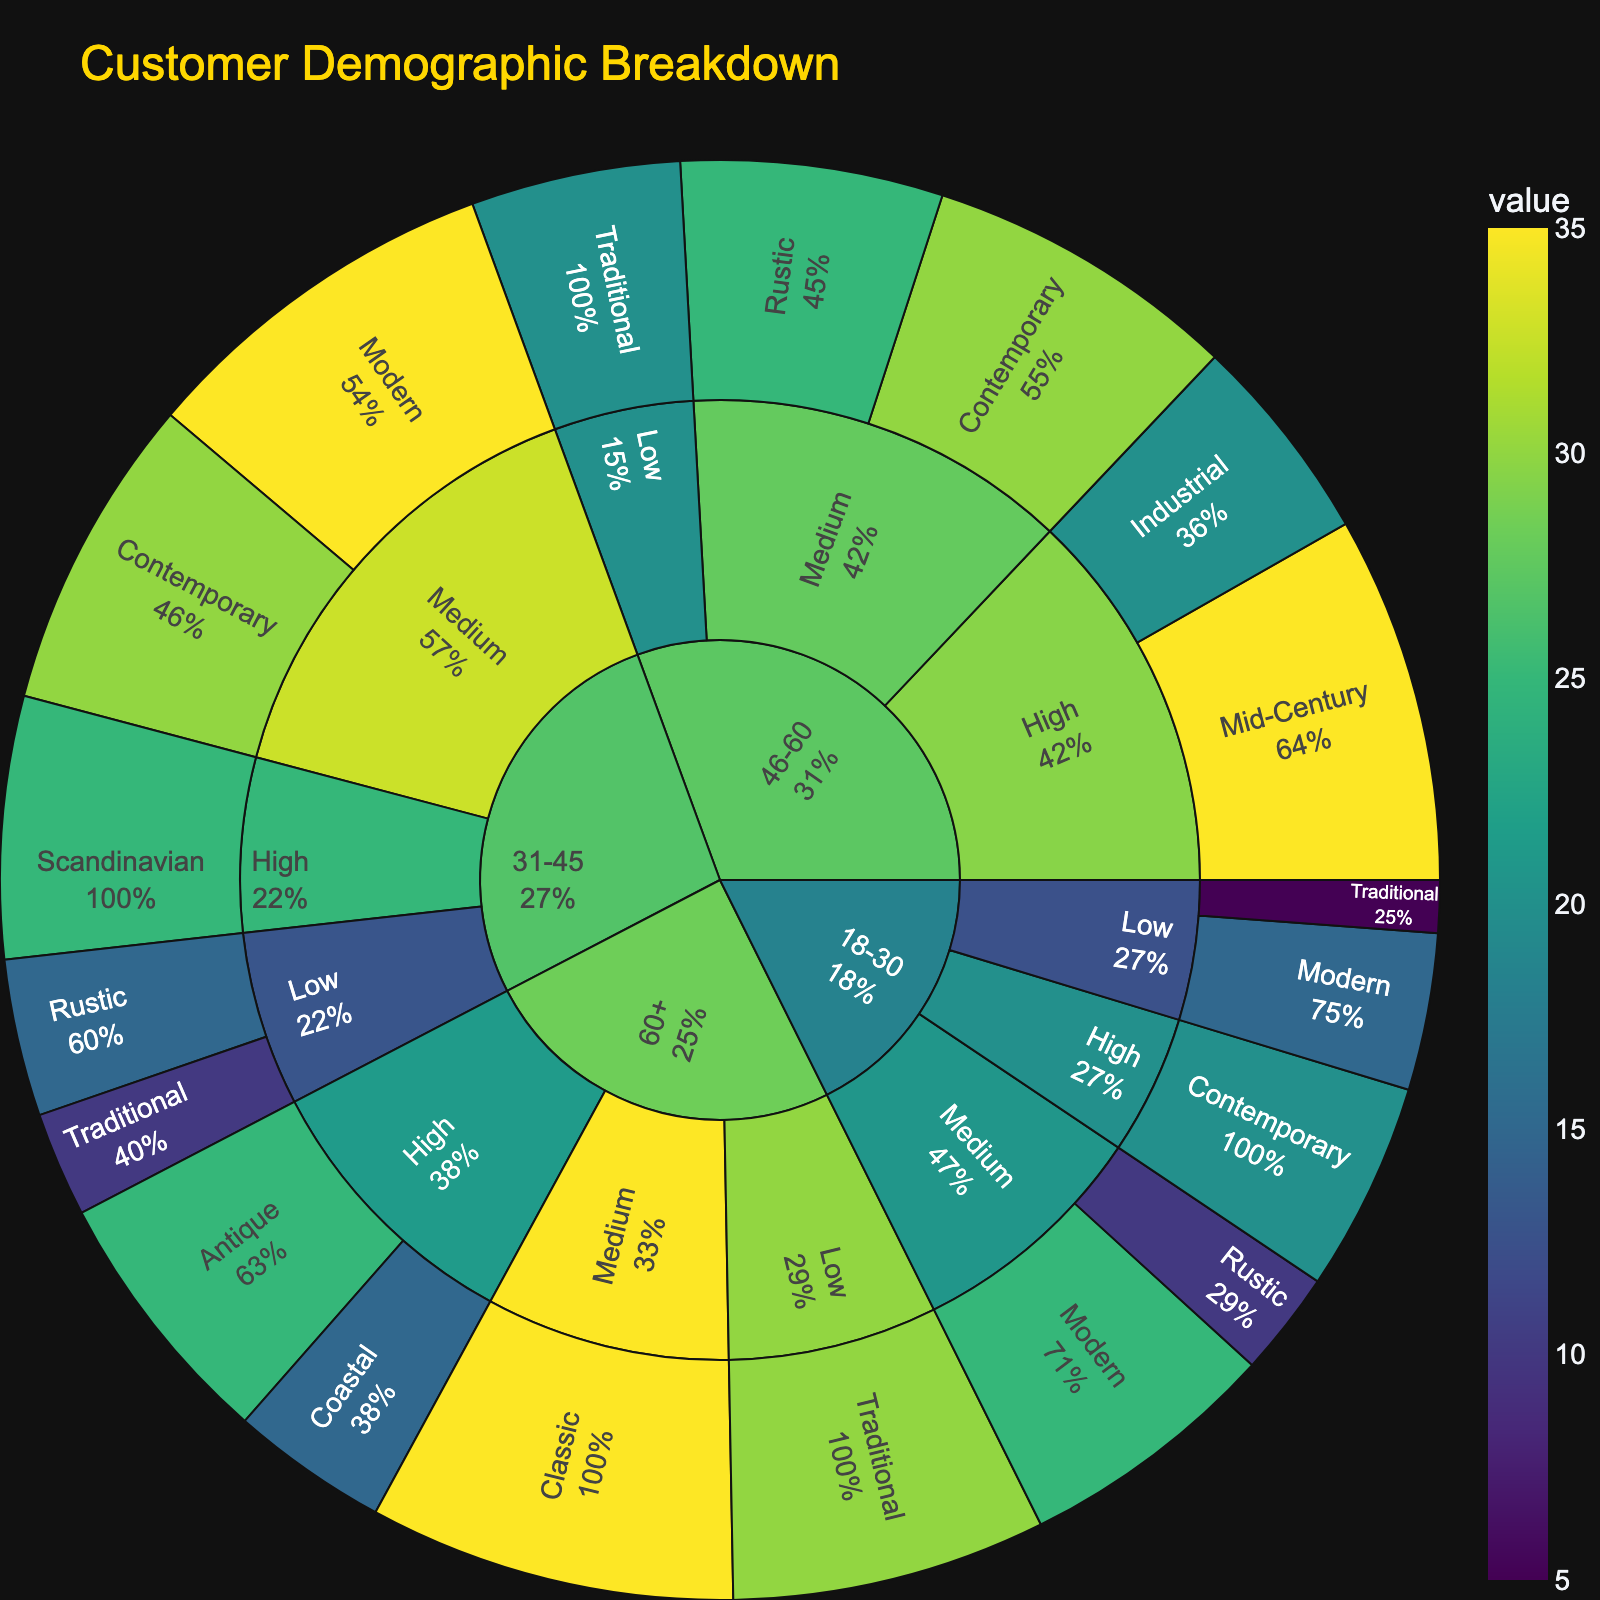what is the title of the sunburst plot? The title of the sunburst plot is located at the top, usually in a larger and distinctive font. It reads "Customer Demographic Breakdown".
Answer: Customer Demographic Breakdown How is the color scheme represented in the plot? The color scheme used in the sunburst plot appears to follow the Viridis color scale, which transitions from shades of yellow to green to blue to purple.
Answer: Viridis color scale Which age group has the largest segment, and what furniture style do they prefer the most? By visually examining the segments, the "31-45" age group appears to have the largest segment. Within this age group, the "Modern" style has the largest segment, as indicated by the size of the arc.
Answer: 31-45, Modern Which income group within the 18-30 age group prefers Modern furniture the most? For the 18-30 age group segment, we can trace inward to determine the income group. The largest segment within the "18-30" age group preferring "Modern" furniture falls under the "Medium" income category, as indicated by the size of the arc.
Answer: Medium How many styles of furniture are preferred by the 60+ age group with high income, and what are they? By examining the segment for "60+" age group with "High" income, the preferred furniture styles are "Antique" and "Coastal", totaling two styles.
Answer: Two styles: Antique and Coastal What percentage of customers aged 46-60 with high income prefer the Industrial style? Locate the "46-60" age group, then high income segment, and finally find the "Industrial" style. The hover text will show the percentage of this specific segment compared to its parent segment.
Answer: Specific percentage from hover text How does the value for Rustic style differ between the 18-30 age group and 31-45 age group with low income? Locate the segment for "Low" income within the "18-30" age group for "Rustic" style and do the same for "31-45". Compare the values shown.
Answer: 10 for 18-30, 15 for 31-45 Which income group within the 31-45 age group shows the highest preference for the Contemporary style? For the 31-45 age group, locate the "Contemporary" style within each income group. The "Medium" income group shows the highest preference, as indicated by the segment’s size.
Answer: Medium What is the cumulative value of the Traditional style preferred by all age groups? Identify the values associated with the "Traditional" style for all age groups and sum them up. Values are 5 (18-30, Low) + 10 (31-45, Low) + 20 (46-60, Low) + 30 (60+, Low) = 65.
Answer: 65 What is the overall favorite furniture style for customers with medium income? Locate the "Medium" income segments in all age groups and compare the segment sizes. The "Modern" style has the largest segment among Medium income groups.
Answer: Modern 